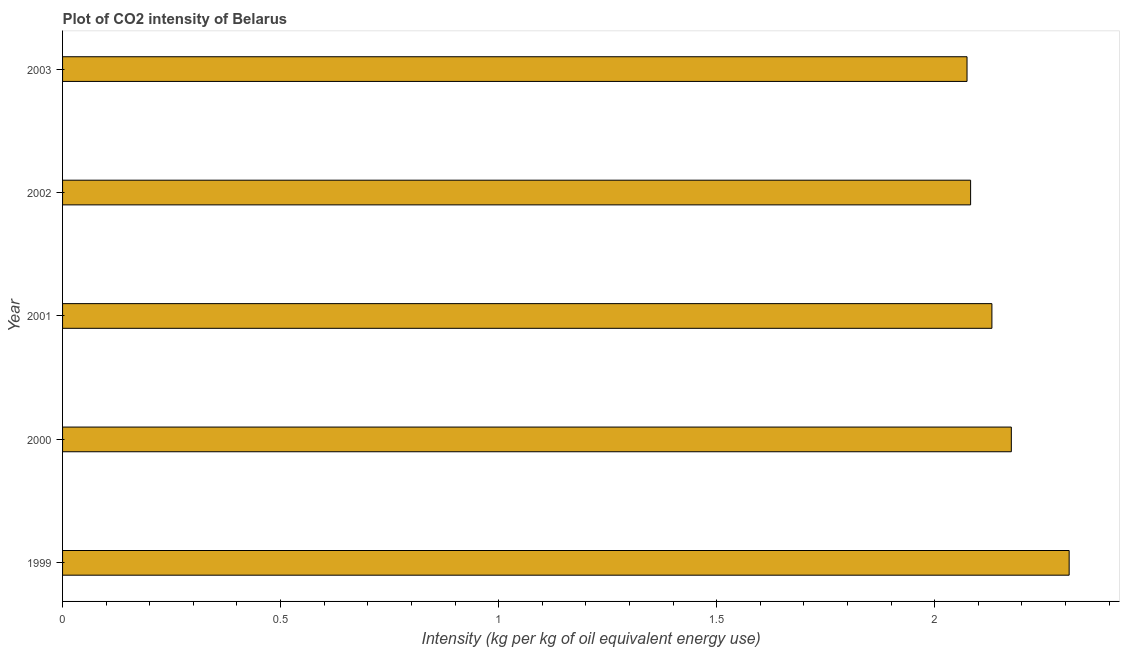Does the graph contain any zero values?
Your answer should be compact. No. Does the graph contain grids?
Provide a short and direct response. No. What is the title of the graph?
Offer a terse response. Plot of CO2 intensity of Belarus. What is the label or title of the X-axis?
Your answer should be compact. Intensity (kg per kg of oil equivalent energy use). What is the co2 intensity in 2003?
Your response must be concise. 2.07. Across all years, what is the maximum co2 intensity?
Your response must be concise. 2.31. Across all years, what is the minimum co2 intensity?
Provide a short and direct response. 2.07. In which year was the co2 intensity maximum?
Your answer should be compact. 1999. What is the sum of the co2 intensity?
Give a very brief answer. 10.77. What is the difference between the co2 intensity in 1999 and 2000?
Provide a succinct answer. 0.13. What is the average co2 intensity per year?
Offer a very short reply. 2.15. What is the median co2 intensity?
Ensure brevity in your answer.  2.13. In how many years, is the co2 intensity greater than 2.2 kg?
Offer a terse response. 1. Is the difference between the co2 intensity in 1999 and 2002 greater than the difference between any two years?
Make the answer very short. No. What is the difference between the highest and the second highest co2 intensity?
Your response must be concise. 0.13. Is the sum of the co2 intensity in 1999 and 2002 greater than the maximum co2 intensity across all years?
Your answer should be compact. Yes. What is the difference between the highest and the lowest co2 intensity?
Offer a terse response. 0.23. How many bars are there?
Provide a succinct answer. 5. What is the difference between two consecutive major ticks on the X-axis?
Keep it short and to the point. 0.5. What is the Intensity (kg per kg of oil equivalent energy use) in 1999?
Make the answer very short. 2.31. What is the Intensity (kg per kg of oil equivalent energy use) of 2000?
Make the answer very short. 2.18. What is the Intensity (kg per kg of oil equivalent energy use) of 2001?
Give a very brief answer. 2.13. What is the Intensity (kg per kg of oil equivalent energy use) in 2002?
Ensure brevity in your answer.  2.08. What is the Intensity (kg per kg of oil equivalent energy use) of 2003?
Your response must be concise. 2.07. What is the difference between the Intensity (kg per kg of oil equivalent energy use) in 1999 and 2000?
Keep it short and to the point. 0.13. What is the difference between the Intensity (kg per kg of oil equivalent energy use) in 1999 and 2001?
Offer a very short reply. 0.18. What is the difference between the Intensity (kg per kg of oil equivalent energy use) in 1999 and 2002?
Your answer should be compact. 0.23. What is the difference between the Intensity (kg per kg of oil equivalent energy use) in 1999 and 2003?
Your answer should be very brief. 0.23. What is the difference between the Intensity (kg per kg of oil equivalent energy use) in 2000 and 2001?
Offer a terse response. 0.04. What is the difference between the Intensity (kg per kg of oil equivalent energy use) in 2000 and 2002?
Give a very brief answer. 0.09. What is the difference between the Intensity (kg per kg of oil equivalent energy use) in 2000 and 2003?
Give a very brief answer. 0.1. What is the difference between the Intensity (kg per kg of oil equivalent energy use) in 2001 and 2002?
Offer a very short reply. 0.05. What is the difference between the Intensity (kg per kg of oil equivalent energy use) in 2001 and 2003?
Your answer should be very brief. 0.06. What is the difference between the Intensity (kg per kg of oil equivalent energy use) in 2002 and 2003?
Your answer should be compact. 0.01. What is the ratio of the Intensity (kg per kg of oil equivalent energy use) in 1999 to that in 2000?
Ensure brevity in your answer.  1.06. What is the ratio of the Intensity (kg per kg of oil equivalent energy use) in 1999 to that in 2001?
Offer a very short reply. 1.08. What is the ratio of the Intensity (kg per kg of oil equivalent energy use) in 1999 to that in 2002?
Make the answer very short. 1.11. What is the ratio of the Intensity (kg per kg of oil equivalent energy use) in 1999 to that in 2003?
Your response must be concise. 1.11. What is the ratio of the Intensity (kg per kg of oil equivalent energy use) in 2000 to that in 2002?
Give a very brief answer. 1.04. What is the ratio of the Intensity (kg per kg of oil equivalent energy use) in 2000 to that in 2003?
Provide a short and direct response. 1.05. What is the ratio of the Intensity (kg per kg of oil equivalent energy use) in 2001 to that in 2003?
Ensure brevity in your answer.  1.03. What is the ratio of the Intensity (kg per kg of oil equivalent energy use) in 2002 to that in 2003?
Provide a succinct answer. 1. 